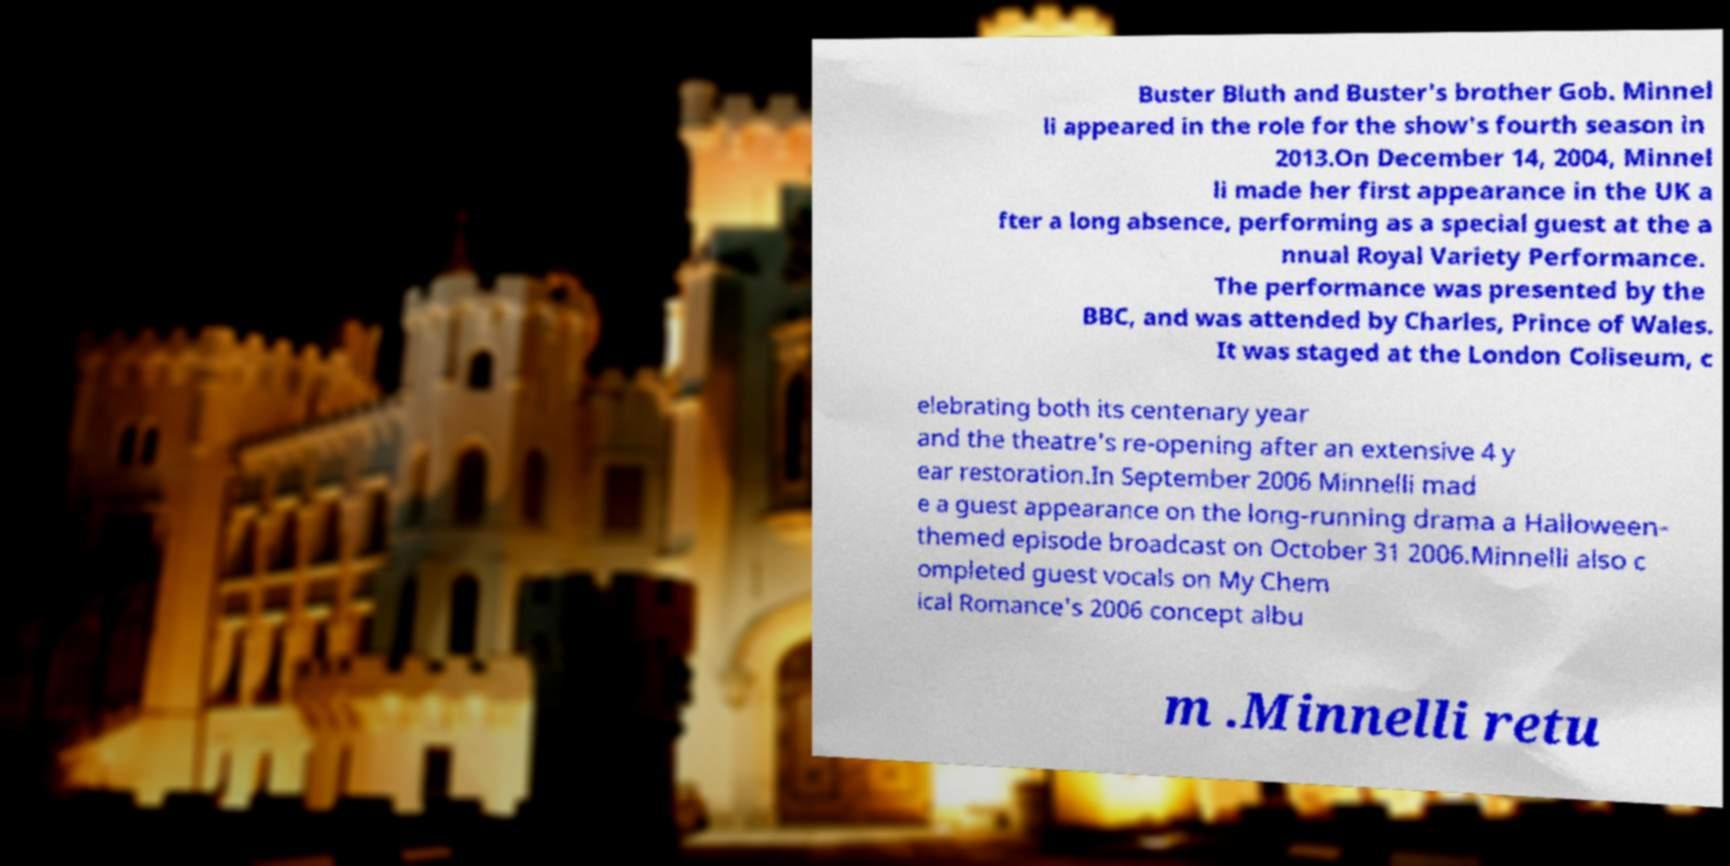Please identify and transcribe the text found in this image. Buster Bluth and Buster's brother Gob. Minnel li appeared in the role for the show's fourth season in 2013.On December 14, 2004, Minnel li made her first appearance in the UK a fter a long absence, performing as a special guest at the a nnual Royal Variety Performance. The performance was presented by the BBC, and was attended by Charles, Prince of Wales. It was staged at the London Coliseum, c elebrating both its centenary year and the theatre's re-opening after an extensive 4 y ear restoration.In September 2006 Minnelli mad e a guest appearance on the long-running drama a Halloween- themed episode broadcast on October 31 2006.Minnelli also c ompleted guest vocals on My Chem ical Romance's 2006 concept albu m .Minnelli retu 